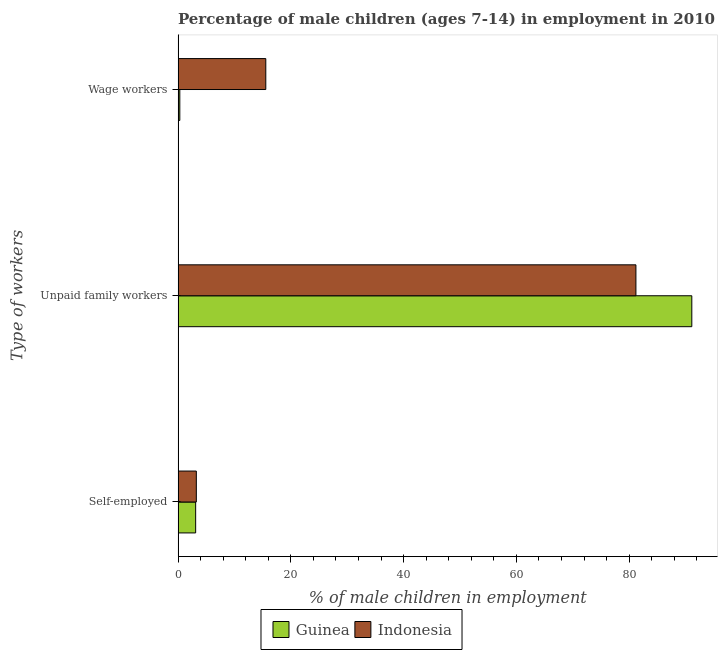How many groups of bars are there?
Keep it short and to the point. 3. What is the label of the 1st group of bars from the top?
Offer a terse response. Wage workers. What is the percentage of children employed as unpaid family workers in Indonesia?
Provide a succinct answer. 81.2. Across all countries, what is the maximum percentage of self employed children?
Keep it short and to the point. 3.24. Across all countries, what is the minimum percentage of children employed as unpaid family workers?
Make the answer very short. 81.2. In which country was the percentage of children employed as unpaid family workers maximum?
Your answer should be very brief. Guinea. In which country was the percentage of children employed as wage workers minimum?
Your answer should be very brief. Guinea. What is the total percentage of children employed as wage workers in the graph?
Give a very brief answer. 15.87. What is the difference between the percentage of children employed as unpaid family workers in Indonesia and that in Guinea?
Offer a very short reply. -9.91. What is the difference between the percentage of children employed as wage workers in Indonesia and the percentage of children employed as unpaid family workers in Guinea?
Your answer should be compact. -75.55. What is the average percentage of children employed as wage workers per country?
Offer a very short reply. 7.94. What is the difference between the percentage of children employed as wage workers and percentage of self employed children in Indonesia?
Your response must be concise. 12.32. In how many countries, is the percentage of self employed children greater than 4 %?
Offer a very short reply. 0. What is the ratio of the percentage of children employed as unpaid family workers in Indonesia to that in Guinea?
Make the answer very short. 0.89. What is the difference between the highest and the second highest percentage of self employed children?
Your answer should be very brief. 0.12. What is the difference between the highest and the lowest percentage of self employed children?
Provide a succinct answer. 0.12. In how many countries, is the percentage of children employed as unpaid family workers greater than the average percentage of children employed as unpaid family workers taken over all countries?
Your answer should be very brief. 1. What does the 1st bar from the top in Unpaid family workers represents?
Your answer should be compact. Indonesia. What does the 1st bar from the bottom in Self-employed represents?
Your answer should be very brief. Guinea. Is it the case that in every country, the sum of the percentage of self employed children and percentage of children employed as unpaid family workers is greater than the percentage of children employed as wage workers?
Offer a terse response. Yes. How many bars are there?
Make the answer very short. 6. How many countries are there in the graph?
Provide a short and direct response. 2. Where does the legend appear in the graph?
Offer a terse response. Bottom center. What is the title of the graph?
Ensure brevity in your answer.  Percentage of male children (ages 7-14) in employment in 2010. Does "Palau" appear as one of the legend labels in the graph?
Ensure brevity in your answer.  No. What is the label or title of the X-axis?
Your response must be concise. % of male children in employment. What is the label or title of the Y-axis?
Provide a short and direct response. Type of workers. What is the % of male children in employment of Guinea in Self-employed?
Provide a succinct answer. 3.12. What is the % of male children in employment of Indonesia in Self-employed?
Offer a terse response. 3.24. What is the % of male children in employment in Guinea in Unpaid family workers?
Provide a succinct answer. 91.11. What is the % of male children in employment of Indonesia in Unpaid family workers?
Ensure brevity in your answer.  81.2. What is the % of male children in employment in Guinea in Wage workers?
Make the answer very short. 0.31. What is the % of male children in employment in Indonesia in Wage workers?
Your response must be concise. 15.56. Across all Type of workers, what is the maximum % of male children in employment in Guinea?
Your answer should be compact. 91.11. Across all Type of workers, what is the maximum % of male children in employment in Indonesia?
Make the answer very short. 81.2. Across all Type of workers, what is the minimum % of male children in employment of Guinea?
Your answer should be very brief. 0.31. Across all Type of workers, what is the minimum % of male children in employment of Indonesia?
Provide a succinct answer. 3.24. What is the total % of male children in employment in Guinea in the graph?
Provide a short and direct response. 94.54. What is the difference between the % of male children in employment in Guinea in Self-employed and that in Unpaid family workers?
Your response must be concise. -87.99. What is the difference between the % of male children in employment of Indonesia in Self-employed and that in Unpaid family workers?
Make the answer very short. -77.96. What is the difference between the % of male children in employment in Guinea in Self-employed and that in Wage workers?
Make the answer very short. 2.81. What is the difference between the % of male children in employment in Indonesia in Self-employed and that in Wage workers?
Offer a terse response. -12.32. What is the difference between the % of male children in employment of Guinea in Unpaid family workers and that in Wage workers?
Ensure brevity in your answer.  90.8. What is the difference between the % of male children in employment of Indonesia in Unpaid family workers and that in Wage workers?
Make the answer very short. 65.64. What is the difference between the % of male children in employment in Guinea in Self-employed and the % of male children in employment in Indonesia in Unpaid family workers?
Your answer should be very brief. -78.08. What is the difference between the % of male children in employment in Guinea in Self-employed and the % of male children in employment in Indonesia in Wage workers?
Your answer should be compact. -12.44. What is the difference between the % of male children in employment of Guinea in Unpaid family workers and the % of male children in employment of Indonesia in Wage workers?
Your answer should be very brief. 75.55. What is the average % of male children in employment of Guinea per Type of workers?
Offer a terse response. 31.51. What is the average % of male children in employment in Indonesia per Type of workers?
Ensure brevity in your answer.  33.33. What is the difference between the % of male children in employment in Guinea and % of male children in employment in Indonesia in Self-employed?
Provide a short and direct response. -0.12. What is the difference between the % of male children in employment in Guinea and % of male children in employment in Indonesia in Unpaid family workers?
Ensure brevity in your answer.  9.91. What is the difference between the % of male children in employment in Guinea and % of male children in employment in Indonesia in Wage workers?
Your answer should be very brief. -15.25. What is the ratio of the % of male children in employment in Guinea in Self-employed to that in Unpaid family workers?
Ensure brevity in your answer.  0.03. What is the ratio of the % of male children in employment in Indonesia in Self-employed to that in Unpaid family workers?
Provide a short and direct response. 0.04. What is the ratio of the % of male children in employment in Guinea in Self-employed to that in Wage workers?
Your answer should be very brief. 10.06. What is the ratio of the % of male children in employment of Indonesia in Self-employed to that in Wage workers?
Offer a terse response. 0.21. What is the ratio of the % of male children in employment of Guinea in Unpaid family workers to that in Wage workers?
Make the answer very short. 293.9. What is the ratio of the % of male children in employment in Indonesia in Unpaid family workers to that in Wage workers?
Your response must be concise. 5.22. What is the difference between the highest and the second highest % of male children in employment in Guinea?
Provide a short and direct response. 87.99. What is the difference between the highest and the second highest % of male children in employment in Indonesia?
Offer a terse response. 65.64. What is the difference between the highest and the lowest % of male children in employment in Guinea?
Provide a succinct answer. 90.8. What is the difference between the highest and the lowest % of male children in employment in Indonesia?
Make the answer very short. 77.96. 